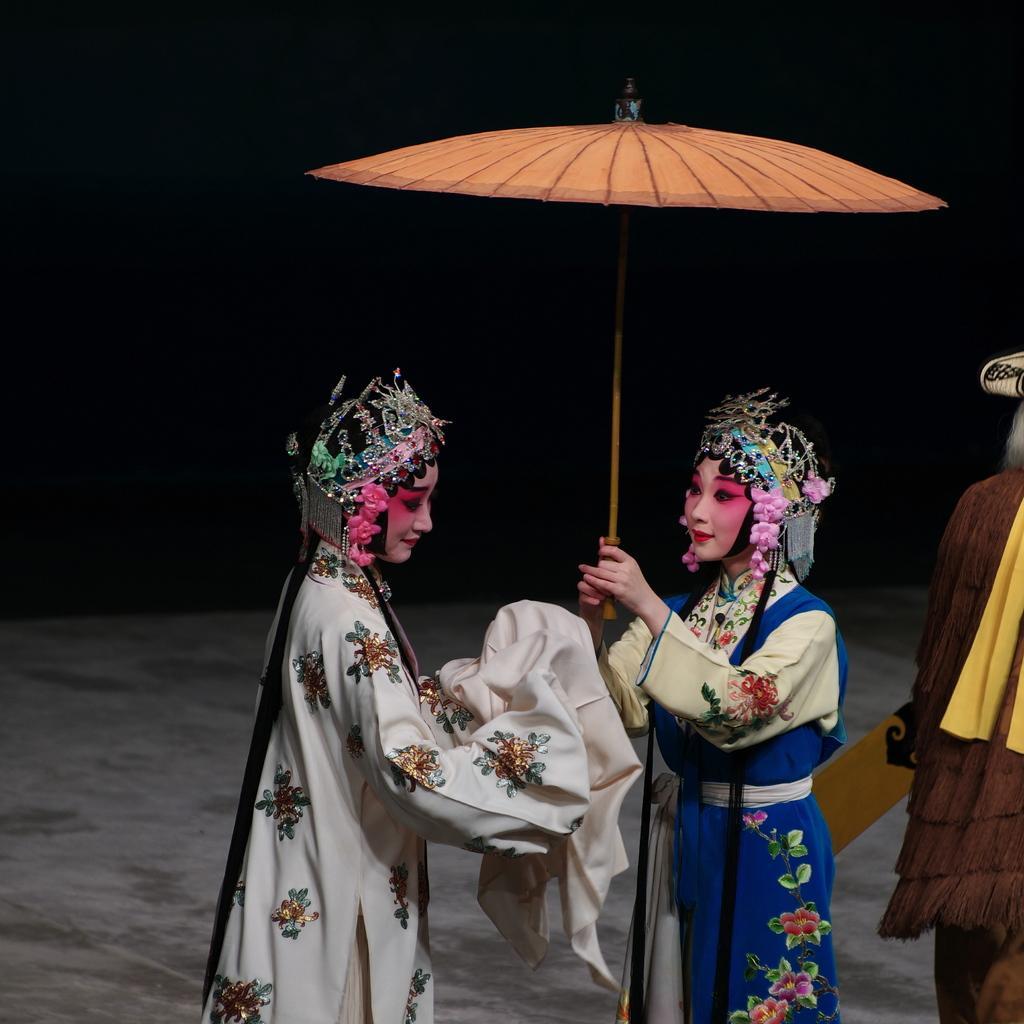In one or two sentences, can you explain what this image depicts? There are two women standing. They wore a fancy dress. This woman is holding an umbrella. On the right side of the image, I can see a person standing. The background looks dark. 